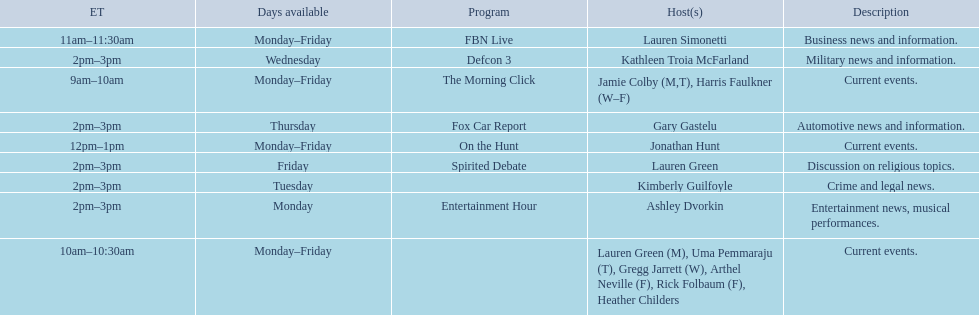Tell me the number of shows that only have one host per day. 7. Help me parse the entirety of this table. {'header': ['ET', 'Days available', 'Program', 'Host(s)', 'Description'], 'rows': [['11am–11:30am', 'Monday–Friday', 'FBN Live', 'Lauren Simonetti', 'Business news and information.'], ['2pm–3pm', 'Wednesday', 'Defcon 3', 'Kathleen Troia McFarland', 'Military news and information.'], ['9am–10am', 'Monday–Friday', 'The Morning Click', 'Jamie Colby (M,T), Harris Faulkner (W–F)', 'Current events.'], ['2pm–3pm', 'Thursday', 'Fox Car Report', 'Gary Gastelu', 'Automotive news and information.'], ['12pm–1pm', 'Monday–Friday', 'On the Hunt', 'Jonathan Hunt', 'Current events.'], ['2pm–3pm', 'Friday', 'Spirited Debate', 'Lauren Green', 'Discussion on religious topics.'], ['2pm–3pm', 'Tuesday', '', 'Kimberly Guilfoyle', 'Crime and legal news.'], ['2pm–3pm', 'Monday', 'Entertainment Hour', 'Ashley Dvorkin', 'Entertainment news, musical performances.'], ['10am–10:30am', 'Monday–Friday', '', 'Lauren Green (M), Uma Pemmaraju (T), Gregg Jarrett (W), Arthel Neville (F), Rick Folbaum (F), Heather Childers', 'Current events.']]} 